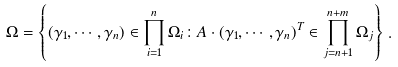<formula> <loc_0><loc_0><loc_500><loc_500>\Omega = \left \{ ( \gamma _ { 1 } , \cdots , \gamma _ { n } ) \in \prod _ { i = 1 } ^ { n } \Omega _ { i } \colon A \cdot ( \gamma _ { 1 } , \cdots , \gamma _ { n } ) ^ { T } \in \prod _ { j = n + 1 } ^ { n + m } \Omega _ { j } \right \} \, .</formula> 